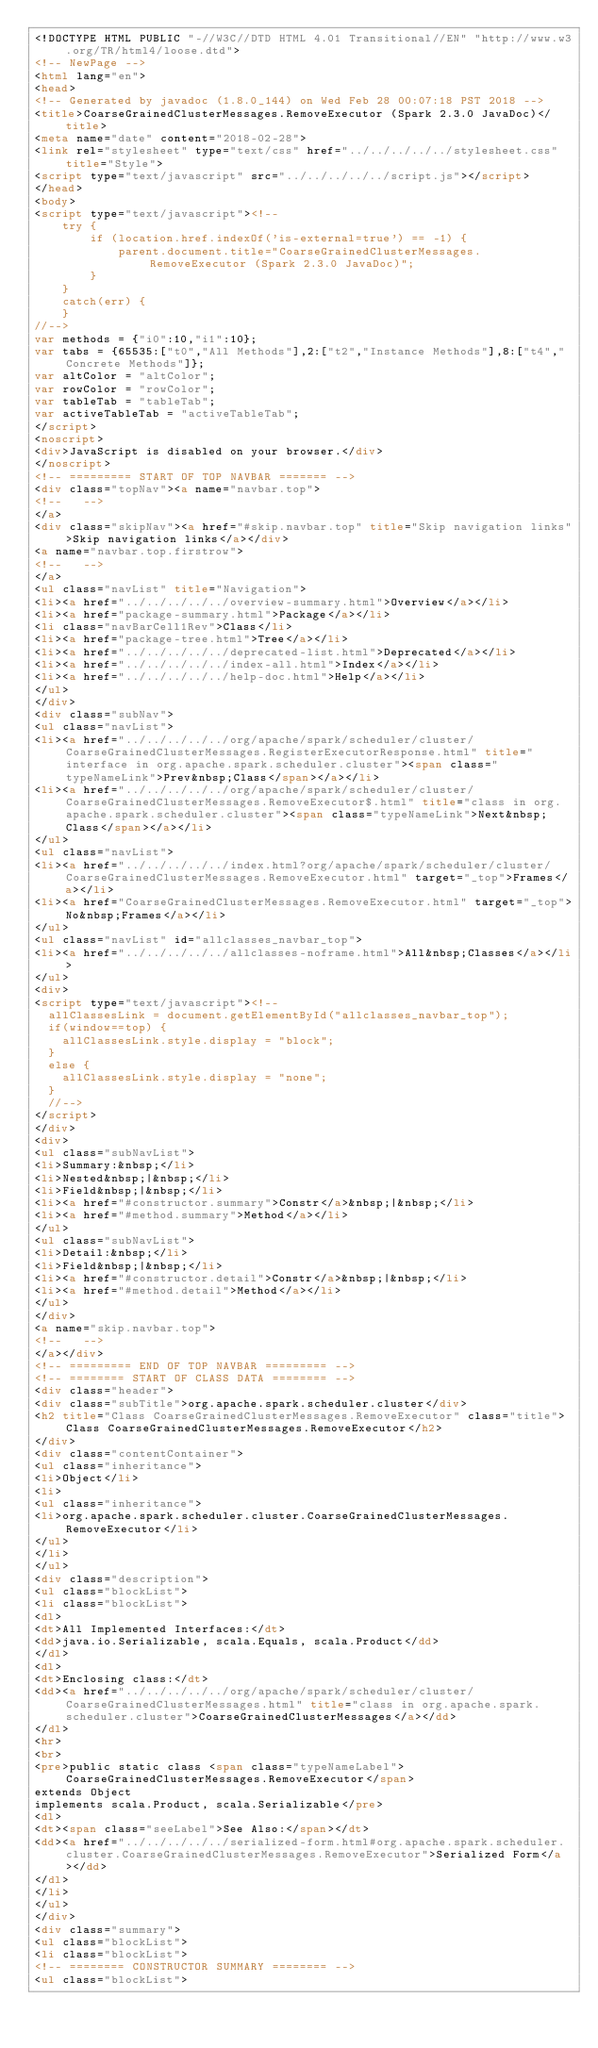<code> <loc_0><loc_0><loc_500><loc_500><_HTML_><!DOCTYPE HTML PUBLIC "-//W3C//DTD HTML 4.01 Transitional//EN" "http://www.w3.org/TR/html4/loose.dtd">
<!-- NewPage -->
<html lang="en">
<head>
<!-- Generated by javadoc (1.8.0_144) on Wed Feb 28 00:07:18 PST 2018 -->
<title>CoarseGrainedClusterMessages.RemoveExecutor (Spark 2.3.0 JavaDoc)</title>
<meta name="date" content="2018-02-28">
<link rel="stylesheet" type="text/css" href="../../../../../stylesheet.css" title="Style">
<script type="text/javascript" src="../../../../../script.js"></script>
</head>
<body>
<script type="text/javascript"><!--
    try {
        if (location.href.indexOf('is-external=true') == -1) {
            parent.document.title="CoarseGrainedClusterMessages.RemoveExecutor (Spark 2.3.0 JavaDoc)";
        }
    }
    catch(err) {
    }
//-->
var methods = {"i0":10,"i1":10};
var tabs = {65535:["t0","All Methods"],2:["t2","Instance Methods"],8:["t4","Concrete Methods"]};
var altColor = "altColor";
var rowColor = "rowColor";
var tableTab = "tableTab";
var activeTableTab = "activeTableTab";
</script>
<noscript>
<div>JavaScript is disabled on your browser.</div>
</noscript>
<!-- ========= START OF TOP NAVBAR ======= -->
<div class="topNav"><a name="navbar.top">
<!--   -->
</a>
<div class="skipNav"><a href="#skip.navbar.top" title="Skip navigation links">Skip navigation links</a></div>
<a name="navbar.top.firstrow">
<!--   -->
</a>
<ul class="navList" title="Navigation">
<li><a href="../../../../../overview-summary.html">Overview</a></li>
<li><a href="package-summary.html">Package</a></li>
<li class="navBarCell1Rev">Class</li>
<li><a href="package-tree.html">Tree</a></li>
<li><a href="../../../../../deprecated-list.html">Deprecated</a></li>
<li><a href="../../../../../index-all.html">Index</a></li>
<li><a href="../../../../../help-doc.html">Help</a></li>
</ul>
</div>
<div class="subNav">
<ul class="navList">
<li><a href="../../../../../org/apache/spark/scheduler/cluster/CoarseGrainedClusterMessages.RegisterExecutorResponse.html" title="interface in org.apache.spark.scheduler.cluster"><span class="typeNameLink">Prev&nbsp;Class</span></a></li>
<li><a href="../../../../../org/apache/spark/scheduler/cluster/CoarseGrainedClusterMessages.RemoveExecutor$.html" title="class in org.apache.spark.scheduler.cluster"><span class="typeNameLink">Next&nbsp;Class</span></a></li>
</ul>
<ul class="navList">
<li><a href="../../../../../index.html?org/apache/spark/scheduler/cluster/CoarseGrainedClusterMessages.RemoveExecutor.html" target="_top">Frames</a></li>
<li><a href="CoarseGrainedClusterMessages.RemoveExecutor.html" target="_top">No&nbsp;Frames</a></li>
</ul>
<ul class="navList" id="allclasses_navbar_top">
<li><a href="../../../../../allclasses-noframe.html">All&nbsp;Classes</a></li>
</ul>
<div>
<script type="text/javascript"><!--
  allClassesLink = document.getElementById("allclasses_navbar_top");
  if(window==top) {
    allClassesLink.style.display = "block";
  }
  else {
    allClassesLink.style.display = "none";
  }
  //-->
</script>
</div>
<div>
<ul class="subNavList">
<li>Summary:&nbsp;</li>
<li>Nested&nbsp;|&nbsp;</li>
<li>Field&nbsp;|&nbsp;</li>
<li><a href="#constructor.summary">Constr</a>&nbsp;|&nbsp;</li>
<li><a href="#method.summary">Method</a></li>
</ul>
<ul class="subNavList">
<li>Detail:&nbsp;</li>
<li>Field&nbsp;|&nbsp;</li>
<li><a href="#constructor.detail">Constr</a>&nbsp;|&nbsp;</li>
<li><a href="#method.detail">Method</a></li>
</ul>
</div>
<a name="skip.navbar.top">
<!--   -->
</a></div>
<!-- ========= END OF TOP NAVBAR ========= -->
<!-- ======== START OF CLASS DATA ======== -->
<div class="header">
<div class="subTitle">org.apache.spark.scheduler.cluster</div>
<h2 title="Class CoarseGrainedClusterMessages.RemoveExecutor" class="title">Class CoarseGrainedClusterMessages.RemoveExecutor</h2>
</div>
<div class="contentContainer">
<ul class="inheritance">
<li>Object</li>
<li>
<ul class="inheritance">
<li>org.apache.spark.scheduler.cluster.CoarseGrainedClusterMessages.RemoveExecutor</li>
</ul>
</li>
</ul>
<div class="description">
<ul class="blockList">
<li class="blockList">
<dl>
<dt>All Implemented Interfaces:</dt>
<dd>java.io.Serializable, scala.Equals, scala.Product</dd>
</dl>
<dl>
<dt>Enclosing class:</dt>
<dd><a href="../../../../../org/apache/spark/scheduler/cluster/CoarseGrainedClusterMessages.html" title="class in org.apache.spark.scheduler.cluster">CoarseGrainedClusterMessages</a></dd>
</dl>
<hr>
<br>
<pre>public static class <span class="typeNameLabel">CoarseGrainedClusterMessages.RemoveExecutor</span>
extends Object
implements scala.Product, scala.Serializable</pre>
<dl>
<dt><span class="seeLabel">See Also:</span></dt>
<dd><a href="../../../../../serialized-form.html#org.apache.spark.scheduler.cluster.CoarseGrainedClusterMessages.RemoveExecutor">Serialized Form</a></dd>
</dl>
</li>
</ul>
</div>
<div class="summary">
<ul class="blockList">
<li class="blockList">
<!-- ======== CONSTRUCTOR SUMMARY ======== -->
<ul class="blockList"></code> 